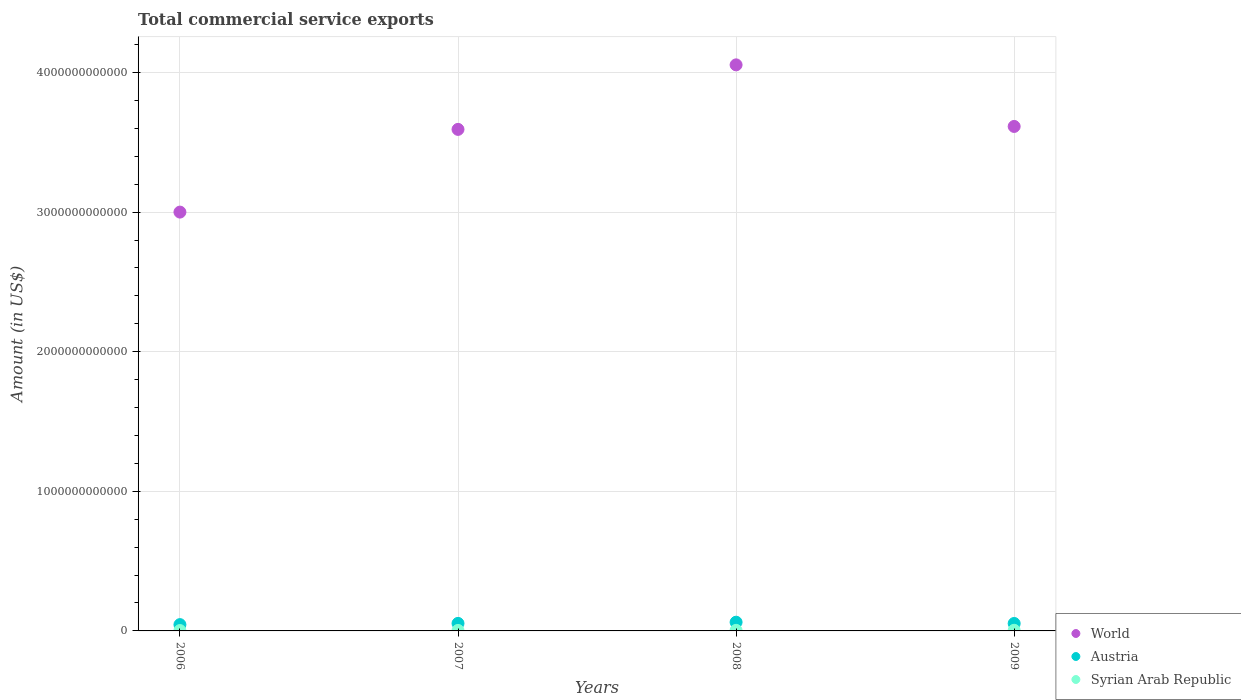How many different coloured dotlines are there?
Offer a very short reply. 3. Is the number of dotlines equal to the number of legend labels?
Provide a succinct answer. Yes. What is the total commercial service exports in World in 2009?
Offer a very short reply. 3.61e+12. Across all years, what is the maximum total commercial service exports in Austria?
Provide a short and direct response. 6.25e+1. Across all years, what is the minimum total commercial service exports in Austria?
Provide a succinct answer. 4.51e+1. What is the total total commercial service exports in Austria in the graph?
Provide a short and direct response. 2.15e+11. What is the difference between the total commercial service exports in Syrian Arab Republic in 2007 and that in 2009?
Your answer should be very brief. -1.02e+09. What is the difference between the total commercial service exports in World in 2006 and the total commercial service exports in Syrian Arab Republic in 2007?
Ensure brevity in your answer.  3.00e+12. What is the average total commercial service exports in Syrian Arab Republic per year?
Provide a succinct answer. 3.73e+09. In the year 2006, what is the difference between the total commercial service exports in Syrian Arab Republic and total commercial service exports in Austria?
Offer a terse response. -4.25e+1. What is the ratio of the total commercial service exports in Austria in 2007 to that in 2009?
Your response must be concise. 1.01. Is the difference between the total commercial service exports in Syrian Arab Republic in 2008 and 2009 greater than the difference between the total commercial service exports in Austria in 2008 and 2009?
Offer a terse response. No. What is the difference between the highest and the second highest total commercial service exports in World?
Offer a terse response. 4.41e+11. What is the difference between the highest and the lowest total commercial service exports in Austria?
Give a very brief answer. 1.74e+1. In how many years, is the total commercial service exports in Austria greater than the average total commercial service exports in Austria taken over all years?
Provide a short and direct response. 2. Is it the case that in every year, the sum of the total commercial service exports in World and total commercial service exports in Syrian Arab Republic  is greater than the total commercial service exports in Austria?
Keep it short and to the point. Yes. Is the total commercial service exports in Austria strictly greater than the total commercial service exports in Syrian Arab Republic over the years?
Provide a short and direct response. Yes. How many dotlines are there?
Give a very brief answer. 3. How many years are there in the graph?
Ensure brevity in your answer.  4. What is the difference between two consecutive major ticks on the Y-axis?
Keep it short and to the point. 1.00e+12. Does the graph contain grids?
Give a very brief answer. Yes. Where does the legend appear in the graph?
Make the answer very short. Bottom right. How are the legend labels stacked?
Keep it short and to the point. Vertical. What is the title of the graph?
Give a very brief answer. Total commercial service exports. Does "Haiti" appear as one of the legend labels in the graph?
Provide a succinct answer. No. What is the Amount (in US$) of World in 2006?
Give a very brief answer. 3.00e+12. What is the Amount (in US$) in Austria in 2006?
Offer a very short reply. 4.51e+1. What is the Amount (in US$) of Syrian Arab Republic in 2006?
Your response must be concise. 2.65e+09. What is the Amount (in US$) in World in 2007?
Your answer should be compact. 3.59e+12. What is the Amount (in US$) of Austria in 2007?
Offer a very short reply. 5.39e+1. What is the Amount (in US$) in Syrian Arab Republic in 2007?
Provide a short and direct response. 3.56e+09. What is the Amount (in US$) of World in 2008?
Your answer should be very brief. 4.05e+12. What is the Amount (in US$) in Austria in 2008?
Give a very brief answer. 6.25e+1. What is the Amount (in US$) in Syrian Arab Republic in 2008?
Provide a succinct answer. 4.15e+09. What is the Amount (in US$) of World in 2009?
Ensure brevity in your answer.  3.61e+12. What is the Amount (in US$) of Austria in 2009?
Your answer should be compact. 5.33e+1. What is the Amount (in US$) in Syrian Arab Republic in 2009?
Provide a short and direct response. 4.58e+09. Across all years, what is the maximum Amount (in US$) in World?
Your response must be concise. 4.05e+12. Across all years, what is the maximum Amount (in US$) of Austria?
Ensure brevity in your answer.  6.25e+1. Across all years, what is the maximum Amount (in US$) in Syrian Arab Republic?
Offer a very short reply. 4.58e+09. Across all years, what is the minimum Amount (in US$) of World?
Your answer should be compact. 3.00e+12. Across all years, what is the minimum Amount (in US$) of Austria?
Provide a short and direct response. 4.51e+1. Across all years, what is the minimum Amount (in US$) in Syrian Arab Republic?
Make the answer very short. 2.65e+09. What is the total Amount (in US$) in World in the graph?
Offer a very short reply. 1.43e+13. What is the total Amount (in US$) of Austria in the graph?
Provide a succinct answer. 2.15e+11. What is the total Amount (in US$) of Syrian Arab Republic in the graph?
Keep it short and to the point. 1.49e+1. What is the difference between the Amount (in US$) in World in 2006 and that in 2007?
Provide a succinct answer. -5.92e+11. What is the difference between the Amount (in US$) of Austria in 2006 and that in 2007?
Offer a very short reply. -8.73e+09. What is the difference between the Amount (in US$) of Syrian Arab Republic in 2006 and that in 2007?
Ensure brevity in your answer.  -9.12e+08. What is the difference between the Amount (in US$) of World in 2006 and that in 2008?
Make the answer very short. -1.05e+12. What is the difference between the Amount (in US$) of Austria in 2006 and that in 2008?
Offer a very short reply. -1.74e+1. What is the difference between the Amount (in US$) of Syrian Arab Republic in 2006 and that in 2008?
Provide a succinct answer. -1.50e+09. What is the difference between the Amount (in US$) of World in 2006 and that in 2009?
Offer a terse response. -6.14e+11. What is the difference between the Amount (in US$) of Austria in 2006 and that in 2009?
Your response must be concise. -8.19e+09. What is the difference between the Amount (in US$) in Syrian Arab Republic in 2006 and that in 2009?
Provide a succinct answer. -1.93e+09. What is the difference between the Amount (in US$) in World in 2007 and that in 2008?
Your answer should be compact. -4.62e+11. What is the difference between the Amount (in US$) of Austria in 2007 and that in 2008?
Your response must be concise. -8.62e+09. What is the difference between the Amount (in US$) of Syrian Arab Republic in 2007 and that in 2008?
Give a very brief answer. -5.84e+08. What is the difference between the Amount (in US$) of World in 2007 and that in 2009?
Offer a terse response. -2.11e+1. What is the difference between the Amount (in US$) in Austria in 2007 and that in 2009?
Ensure brevity in your answer.  5.48e+08. What is the difference between the Amount (in US$) in Syrian Arab Republic in 2007 and that in 2009?
Offer a very short reply. -1.02e+09. What is the difference between the Amount (in US$) in World in 2008 and that in 2009?
Your answer should be compact. 4.41e+11. What is the difference between the Amount (in US$) in Austria in 2008 and that in 2009?
Make the answer very short. 9.17e+09. What is the difference between the Amount (in US$) of Syrian Arab Republic in 2008 and that in 2009?
Offer a very short reply. -4.38e+08. What is the difference between the Amount (in US$) of World in 2006 and the Amount (in US$) of Austria in 2007?
Offer a terse response. 2.95e+12. What is the difference between the Amount (in US$) of World in 2006 and the Amount (in US$) of Syrian Arab Republic in 2007?
Give a very brief answer. 3.00e+12. What is the difference between the Amount (in US$) in Austria in 2006 and the Amount (in US$) in Syrian Arab Republic in 2007?
Provide a succinct answer. 4.16e+1. What is the difference between the Amount (in US$) in World in 2006 and the Amount (in US$) in Austria in 2008?
Offer a very short reply. 2.94e+12. What is the difference between the Amount (in US$) in World in 2006 and the Amount (in US$) in Syrian Arab Republic in 2008?
Your answer should be very brief. 3.00e+12. What is the difference between the Amount (in US$) in Austria in 2006 and the Amount (in US$) in Syrian Arab Republic in 2008?
Give a very brief answer. 4.10e+1. What is the difference between the Amount (in US$) of World in 2006 and the Amount (in US$) of Austria in 2009?
Ensure brevity in your answer.  2.95e+12. What is the difference between the Amount (in US$) of World in 2006 and the Amount (in US$) of Syrian Arab Republic in 2009?
Make the answer very short. 3.00e+12. What is the difference between the Amount (in US$) in Austria in 2006 and the Amount (in US$) in Syrian Arab Republic in 2009?
Give a very brief answer. 4.06e+1. What is the difference between the Amount (in US$) in World in 2007 and the Amount (in US$) in Austria in 2008?
Your response must be concise. 3.53e+12. What is the difference between the Amount (in US$) of World in 2007 and the Amount (in US$) of Syrian Arab Republic in 2008?
Offer a very short reply. 3.59e+12. What is the difference between the Amount (in US$) in Austria in 2007 and the Amount (in US$) in Syrian Arab Republic in 2008?
Your answer should be compact. 4.97e+1. What is the difference between the Amount (in US$) in World in 2007 and the Amount (in US$) in Austria in 2009?
Offer a terse response. 3.54e+12. What is the difference between the Amount (in US$) in World in 2007 and the Amount (in US$) in Syrian Arab Republic in 2009?
Make the answer very short. 3.59e+12. What is the difference between the Amount (in US$) in Austria in 2007 and the Amount (in US$) in Syrian Arab Republic in 2009?
Keep it short and to the point. 4.93e+1. What is the difference between the Amount (in US$) of World in 2008 and the Amount (in US$) of Austria in 2009?
Provide a succinct answer. 4.00e+12. What is the difference between the Amount (in US$) in World in 2008 and the Amount (in US$) in Syrian Arab Republic in 2009?
Offer a terse response. 4.05e+12. What is the difference between the Amount (in US$) of Austria in 2008 and the Amount (in US$) of Syrian Arab Republic in 2009?
Provide a short and direct response. 5.79e+1. What is the average Amount (in US$) of World per year?
Your answer should be very brief. 3.57e+12. What is the average Amount (in US$) in Austria per year?
Make the answer very short. 5.37e+1. What is the average Amount (in US$) in Syrian Arab Republic per year?
Your response must be concise. 3.73e+09. In the year 2006, what is the difference between the Amount (in US$) of World and Amount (in US$) of Austria?
Offer a very short reply. 2.95e+12. In the year 2006, what is the difference between the Amount (in US$) in World and Amount (in US$) in Syrian Arab Republic?
Offer a very short reply. 3.00e+12. In the year 2006, what is the difference between the Amount (in US$) of Austria and Amount (in US$) of Syrian Arab Republic?
Your response must be concise. 4.25e+1. In the year 2007, what is the difference between the Amount (in US$) in World and Amount (in US$) in Austria?
Ensure brevity in your answer.  3.54e+12. In the year 2007, what is the difference between the Amount (in US$) of World and Amount (in US$) of Syrian Arab Republic?
Give a very brief answer. 3.59e+12. In the year 2007, what is the difference between the Amount (in US$) in Austria and Amount (in US$) in Syrian Arab Republic?
Offer a very short reply. 5.03e+1. In the year 2008, what is the difference between the Amount (in US$) of World and Amount (in US$) of Austria?
Offer a very short reply. 3.99e+12. In the year 2008, what is the difference between the Amount (in US$) in World and Amount (in US$) in Syrian Arab Republic?
Your answer should be compact. 4.05e+12. In the year 2008, what is the difference between the Amount (in US$) in Austria and Amount (in US$) in Syrian Arab Republic?
Ensure brevity in your answer.  5.83e+1. In the year 2009, what is the difference between the Amount (in US$) in World and Amount (in US$) in Austria?
Offer a terse response. 3.56e+12. In the year 2009, what is the difference between the Amount (in US$) in World and Amount (in US$) in Syrian Arab Republic?
Give a very brief answer. 3.61e+12. In the year 2009, what is the difference between the Amount (in US$) of Austria and Amount (in US$) of Syrian Arab Republic?
Ensure brevity in your answer.  4.87e+1. What is the ratio of the Amount (in US$) in World in 2006 to that in 2007?
Your answer should be compact. 0.84. What is the ratio of the Amount (in US$) of Austria in 2006 to that in 2007?
Your answer should be compact. 0.84. What is the ratio of the Amount (in US$) in Syrian Arab Republic in 2006 to that in 2007?
Ensure brevity in your answer.  0.74. What is the ratio of the Amount (in US$) in World in 2006 to that in 2008?
Provide a succinct answer. 0.74. What is the ratio of the Amount (in US$) of Austria in 2006 to that in 2008?
Provide a succinct answer. 0.72. What is the ratio of the Amount (in US$) in Syrian Arab Republic in 2006 to that in 2008?
Provide a succinct answer. 0.64. What is the ratio of the Amount (in US$) in World in 2006 to that in 2009?
Ensure brevity in your answer.  0.83. What is the ratio of the Amount (in US$) of Austria in 2006 to that in 2009?
Provide a short and direct response. 0.85. What is the ratio of the Amount (in US$) of Syrian Arab Republic in 2006 to that in 2009?
Offer a terse response. 0.58. What is the ratio of the Amount (in US$) in World in 2007 to that in 2008?
Offer a very short reply. 0.89. What is the ratio of the Amount (in US$) of Austria in 2007 to that in 2008?
Ensure brevity in your answer.  0.86. What is the ratio of the Amount (in US$) of Syrian Arab Republic in 2007 to that in 2008?
Make the answer very short. 0.86. What is the ratio of the Amount (in US$) of Austria in 2007 to that in 2009?
Offer a terse response. 1.01. What is the ratio of the Amount (in US$) in Syrian Arab Republic in 2007 to that in 2009?
Your response must be concise. 0.78. What is the ratio of the Amount (in US$) of World in 2008 to that in 2009?
Give a very brief answer. 1.12. What is the ratio of the Amount (in US$) of Austria in 2008 to that in 2009?
Keep it short and to the point. 1.17. What is the ratio of the Amount (in US$) of Syrian Arab Republic in 2008 to that in 2009?
Your answer should be very brief. 0.9. What is the difference between the highest and the second highest Amount (in US$) of World?
Make the answer very short. 4.41e+11. What is the difference between the highest and the second highest Amount (in US$) of Austria?
Make the answer very short. 8.62e+09. What is the difference between the highest and the second highest Amount (in US$) of Syrian Arab Republic?
Give a very brief answer. 4.38e+08. What is the difference between the highest and the lowest Amount (in US$) of World?
Provide a succinct answer. 1.05e+12. What is the difference between the highest and the lowest Amount (in US$) of Austria?
Make the answer very short. 1.74e+1. What is the difference between the highest and the lowest Amount (in US$) of Syrian Arab Republic?
Ensure brevity in your answer.  1.93e+09. 